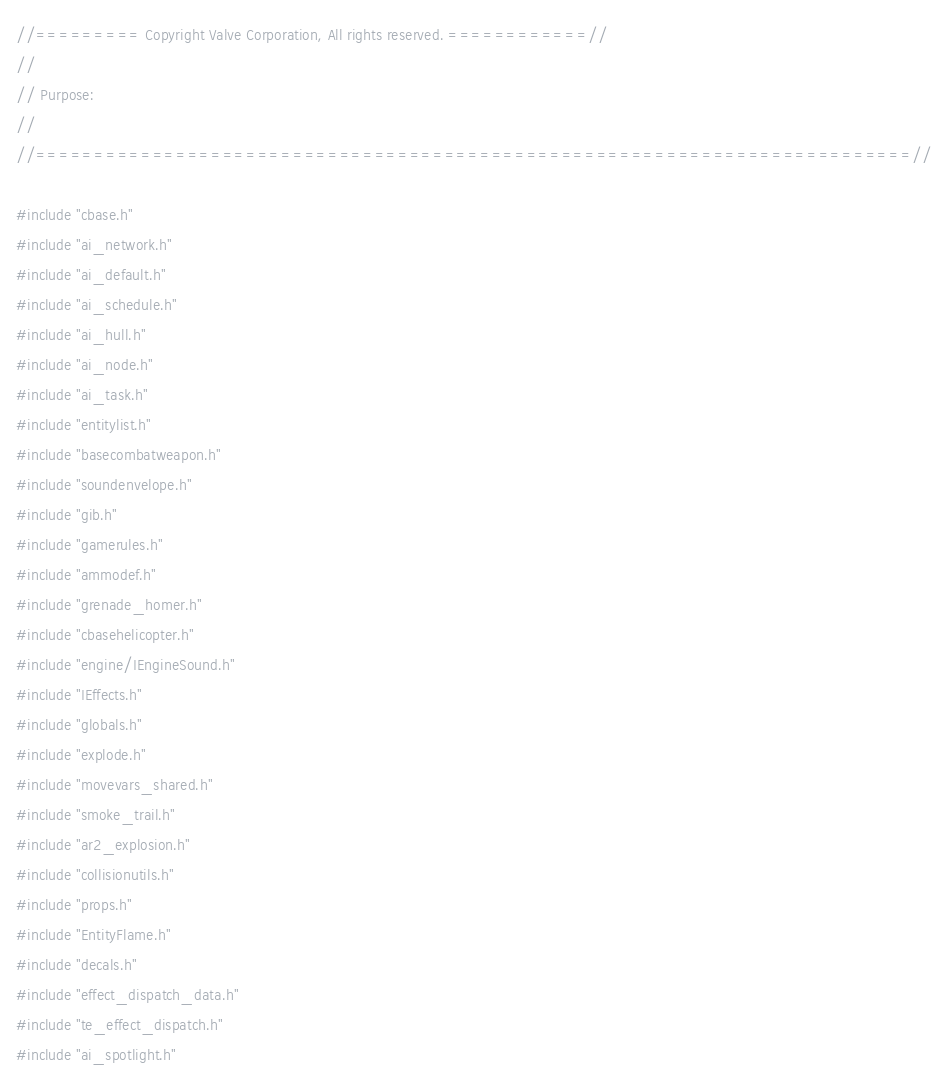<code> <loc_0><loc_0><loc_500><loc_500><_C++_>//========= Copyright Valve Corporation, All rights reserved. ============//
//
// Purpose: 
//
//===========================================================================//

#include "cbase.h"
#include "ai_network.h"
#include "ai_default.h"
#include "ai_schedule.h"
#include "ai_hull.h"
#include "ai_node.h"
#include "ai_task.h"
#include "entitylist.h"
#include "basecombatweapon.h"
#include "soundenvelope.h"
#include "gib.h"
#include "gamerules.h"
#include "ammodef.h"
#include "grenade_homer.h"
#include "cbasehelicopter.h"
#include "engine/IEngineSound.h"
#include "IEffects.h"
#include "globals.h"
#include "explode.h"
#include "movevars_shared.h"
#include "smoke_trail.h"
#include "ar2_explosion.h"
#include "collisionutils.h"
#include "props.h"
#include "EntityFlame.h"
#include "decals.h"
#include "effect_dispatch_data.h"
#include "te_effect_dispatch.h"
#include "ai_spotlight.h"</code> 